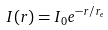Convert formula to latex. <formula><loc_0><loc_0><loc_500><loc_500>I ( r ) = I _ { 0 } e ^ { - r / r _ { e } }</formula> 